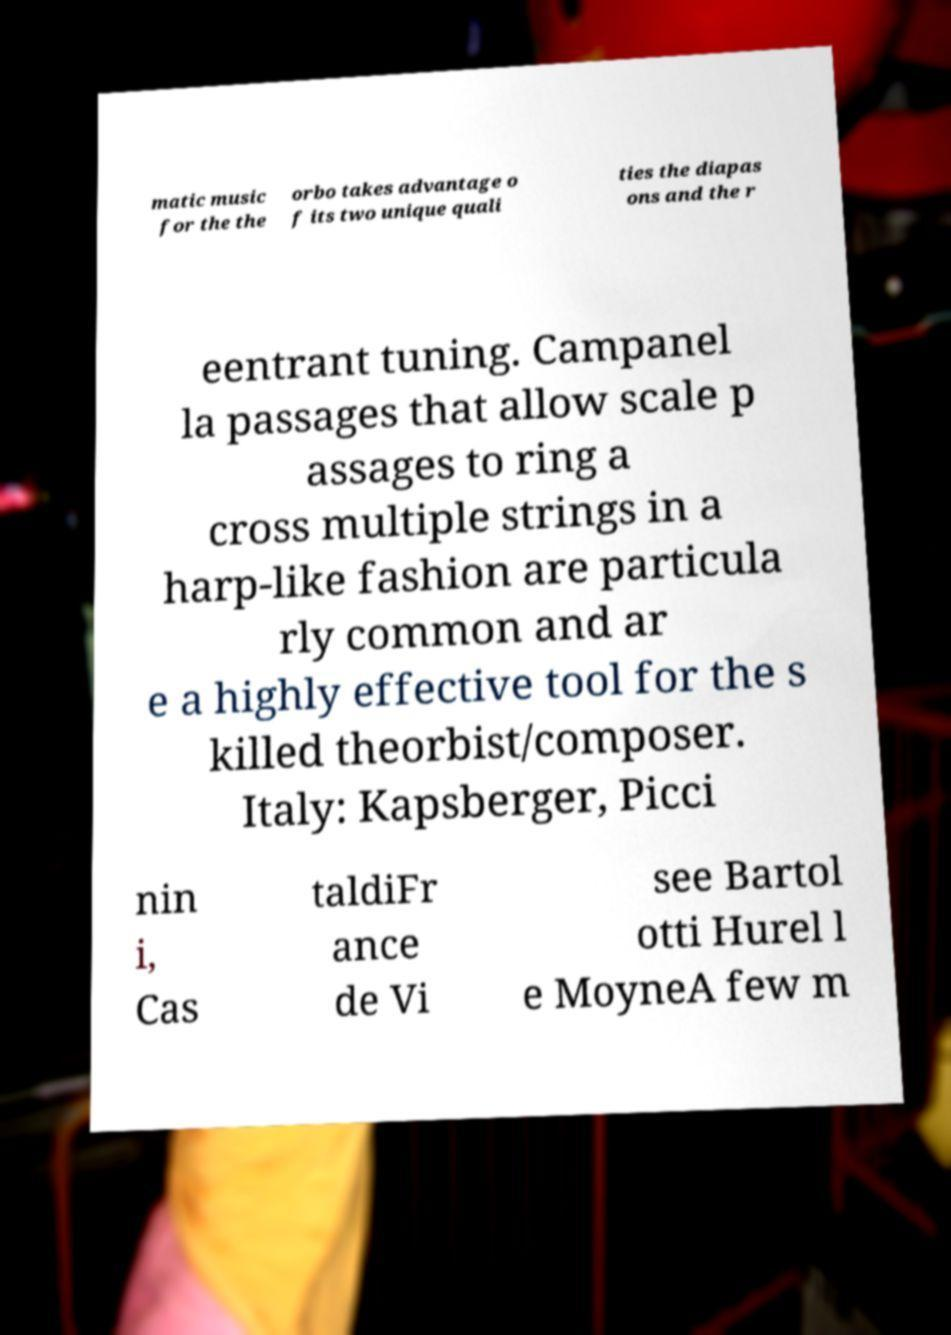For documentation purposes, I need the text within this image transcribed. Could you provide that? matic music for the the orbo takes advantage o f its two unique quali ties the diapas ons and the r eentrant tuning. Campanel la passages that allow scale p assages to ring a cross multiple strings in a harp-like fashion are particula rly common and ar e a highly effective tool for the s killed theorbist/composer. Italy: Kapsberger, Picci nin i, Cas taldiFr ance de Vi see Bartol otti Hurel l e MoyneA few m 